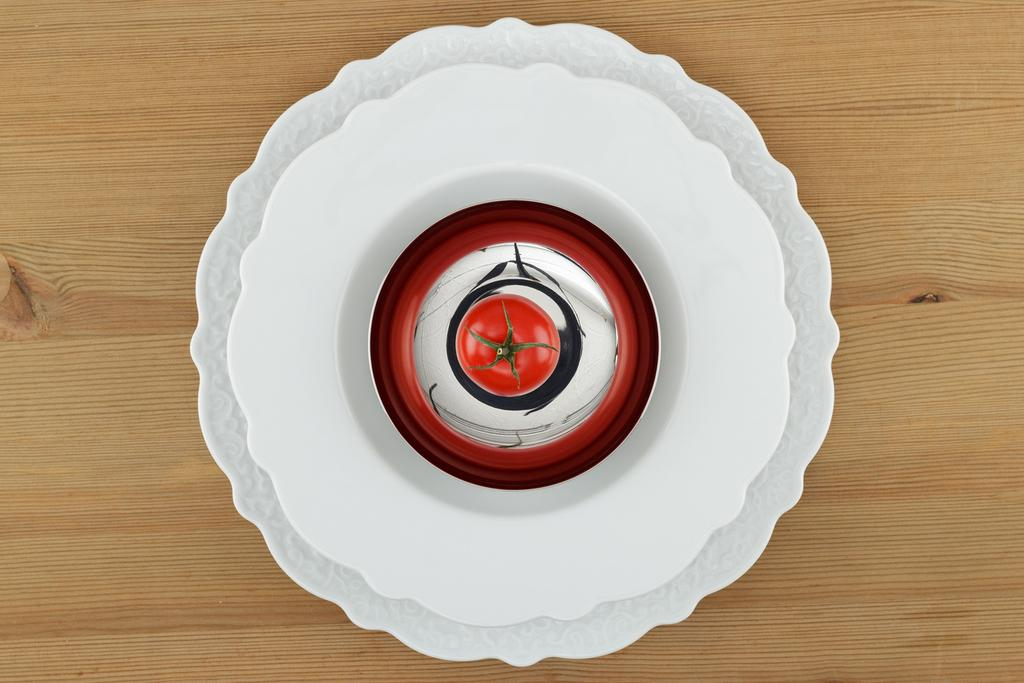What type of fruit is present in the image? There is a tomato in the image. What color is the object next to the tomato? There is a white color object in the image. On what surface are the objects placed? The objects are on a wooden surface. What type of apparel is being worn by the tomato in the image? There is no apparel present in the image, as the tomato is a fruit and not a person or animal. 